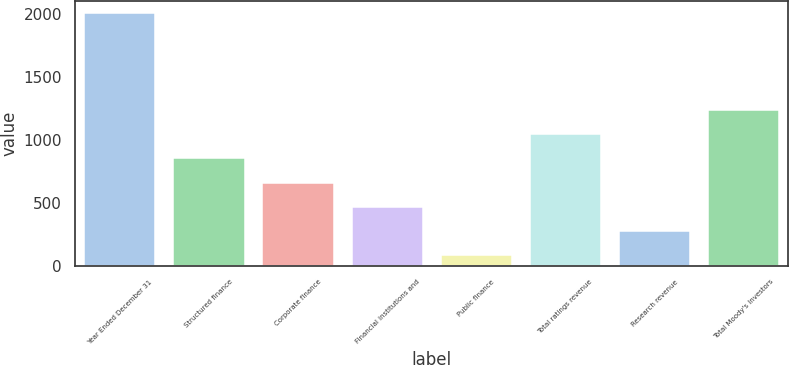Convert chart. <chart><loc_0><loc_0><loc_500><loc_500><bar_chart><fcel>Year Ended December 31<fcel>Structured finance<fcel>Corporate finance<fcel>Financial institutions and<fcel>Public finance<fcel>Total ratings revenue<fcel>Research revenue<fcel>Total Moody's Investors<nl><fcel>2002<fcel>849.52<fcel>657.44<fcel>465.36<fcel>81.2<fcel>1041.6<fcel>273.28<fcel>1233.68<nl></chart> 